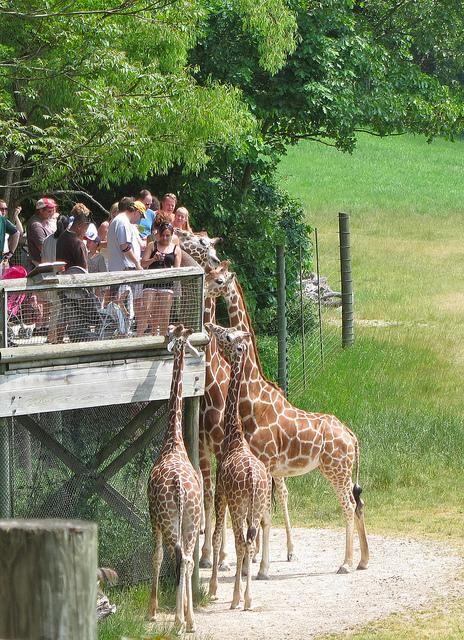Which giraffe left to right has the best chance of getting petted? right 